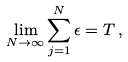<formula> <loc_0><loc_0><loc_500><loc_500>\lim _ { N \rightarrow \infty } \sum _ { j = 1 } ^ { N } \epsilon = T \, ,</formula> 